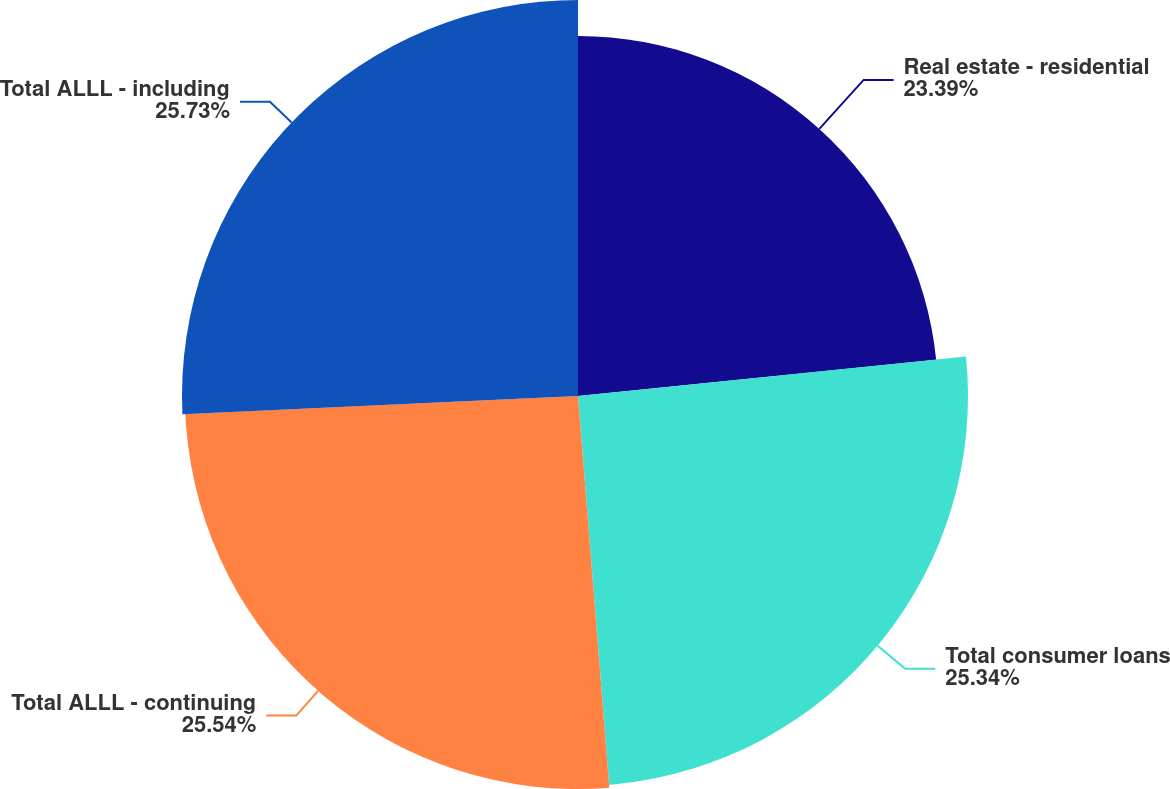<chart> <loc_0><loc_0><loc_500><loc_500><pie_chart><fcel>Real estate - residential<fcel>Total consumer loans<fcel>Total ALLL - continuing<fcel>Total ALLL - including<nl><fcel>23.39%<fcel>25.34%<fcel>25.54%<fcel>25.73%<nl></chart> 